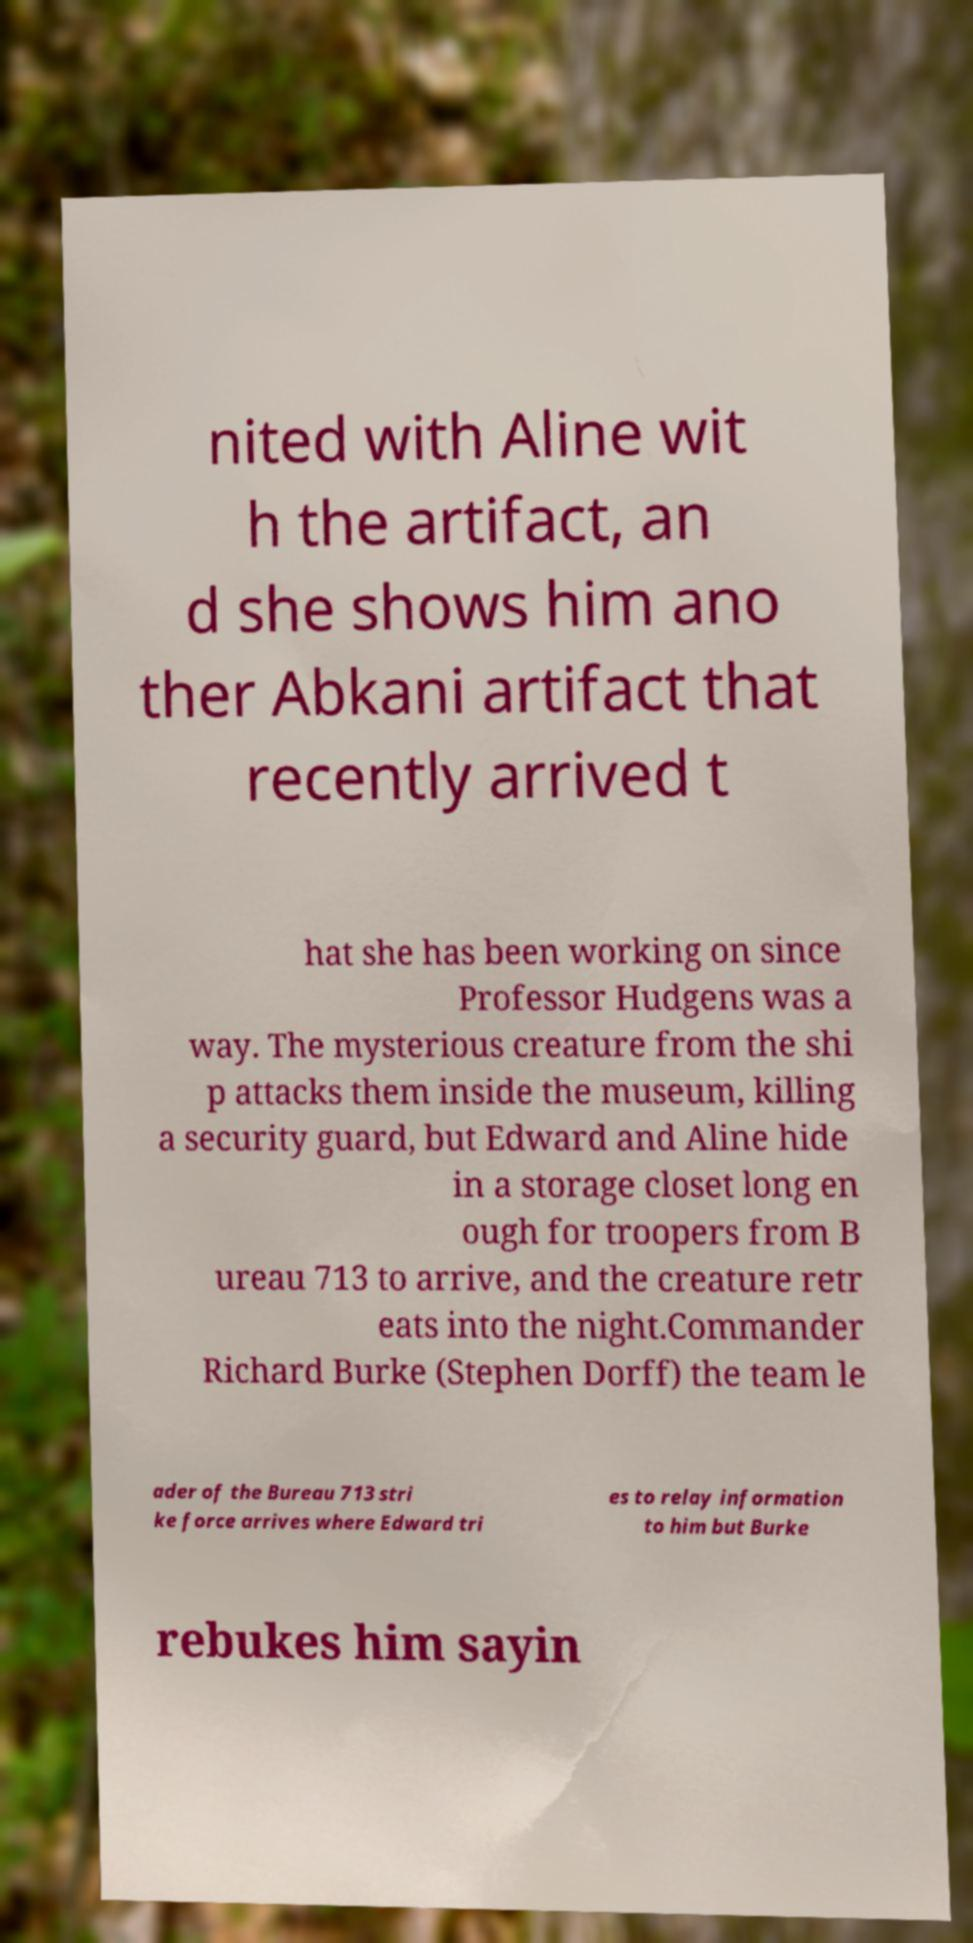Please identify and transcribe the text found in this image. nited with Aline wit h the artifact, an d she shows him ano ther Abkani artifact that recently arrived t hat she has been working on since Professor Hudgens was a way. The mysterious creature from the shi p attacks them inside the museum, killing a security guard, but Edward and Aline hide in a storage closet long en ough for troopers from B ureau 713 to arrive, and the creature retr eats into the night.Commander Richard Burke (Stephen Dorff) the team le ader of the Bureau 713 stri ke force arrives where Edward tri es to relay information to him but Burke rebukes him sayin 